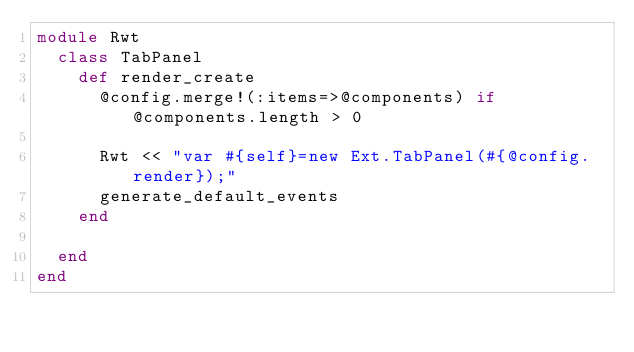Convert code to text. <code><loc_0><loc_0><loc_500><loc_500><_Ruby_>module Rwt
  class TabPanel
    def render_create
      @config.merge!(:items=>@components) if @components.length > 0

      Rwt << "var #{self}=new Ext.TabPanel(#{@config.render});"
      generate_default_events
    end

  end
end
</code> 